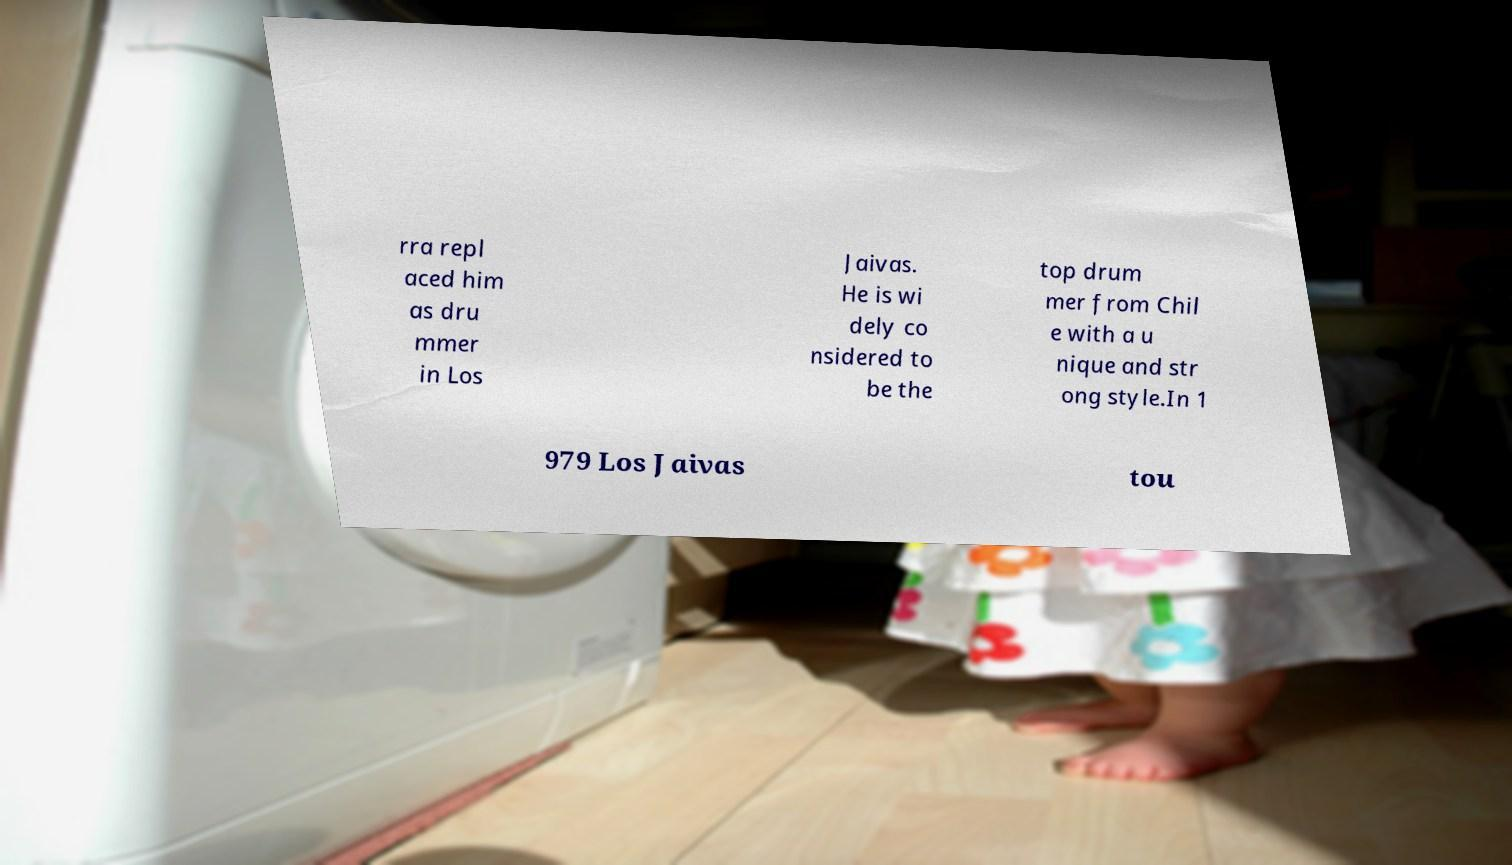Please read and relay the text visible in this image. What does it say? rra repl aced him as dru mmer in Los Jaivas. He is wi dely co nsidered to be the top drum mer from Chil e with a u nique and str ong style.In 1 979 Los Jaivas tou 